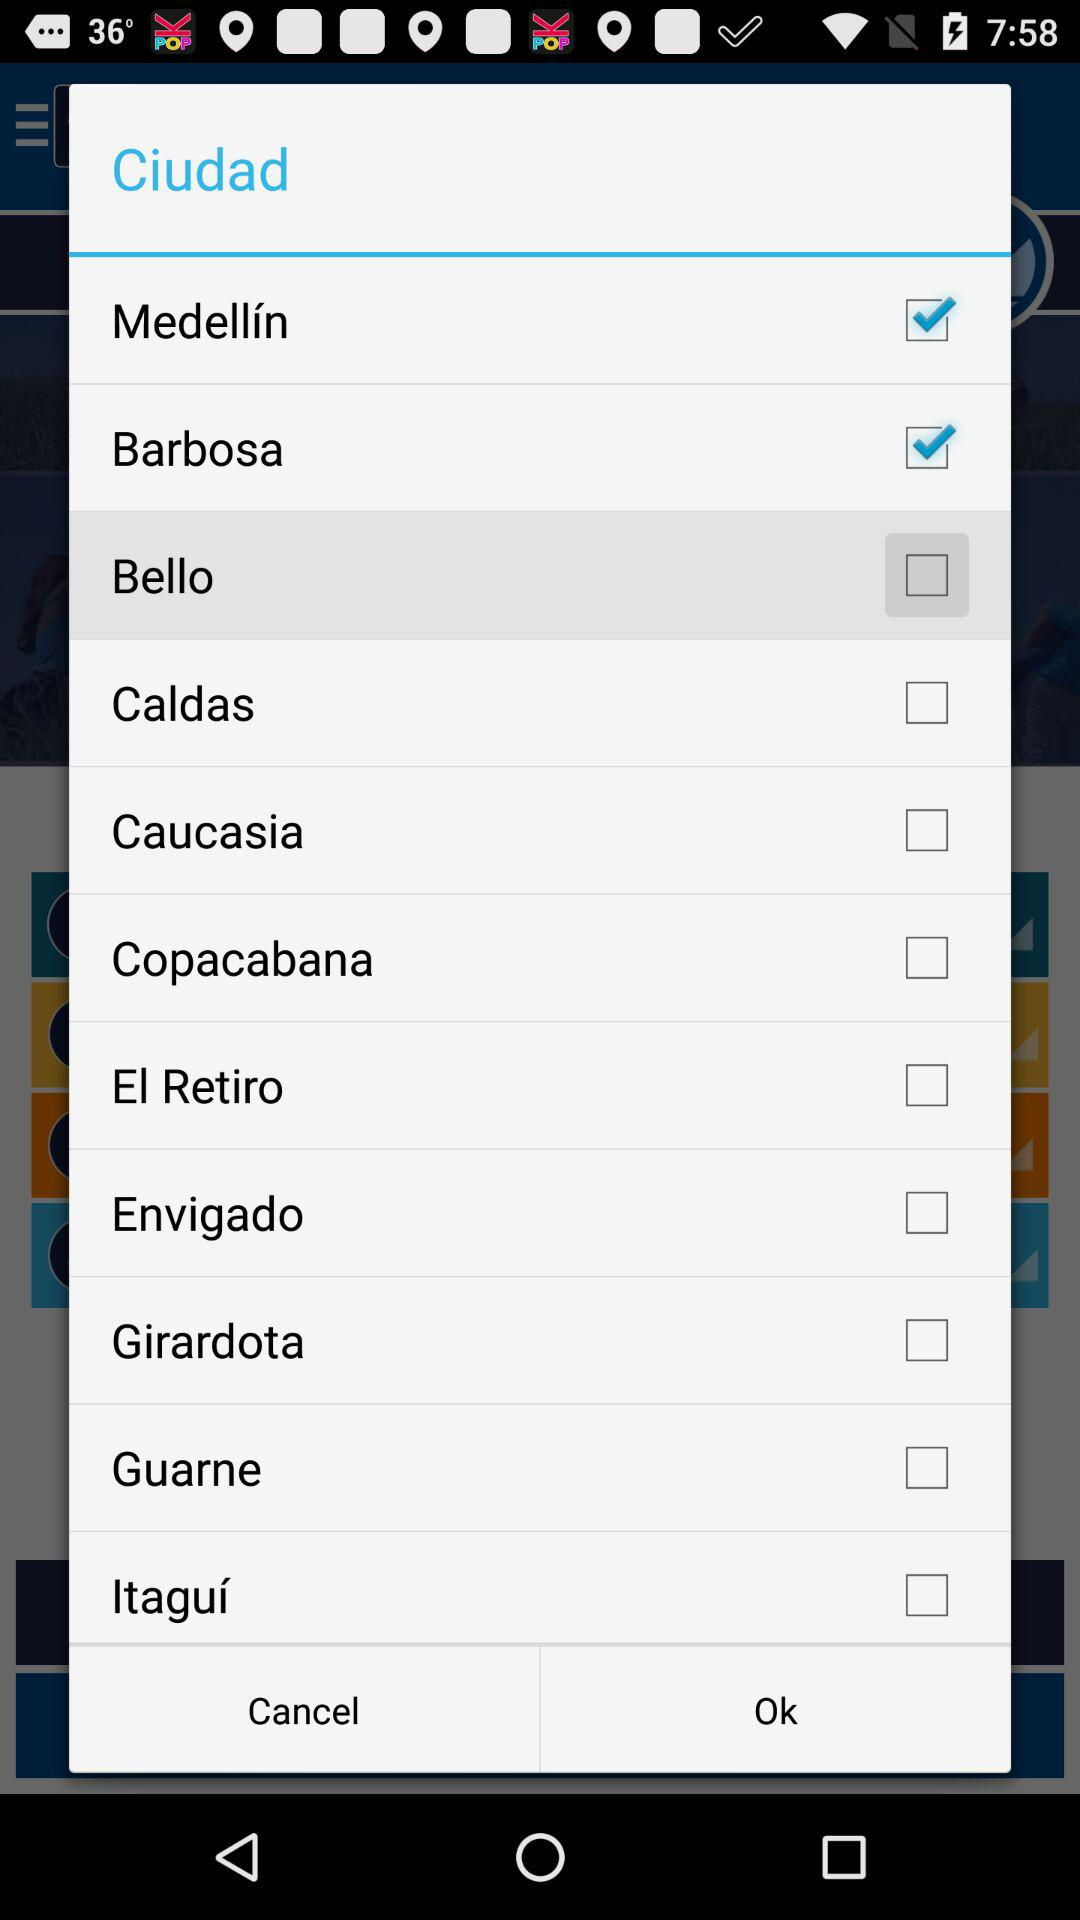What are the checked options in the application? The checked options are "Medellín" and "Barbosa". 